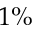<formula> <loc_0><loc_0><loc_500><loc_500>1 \%</formula> 